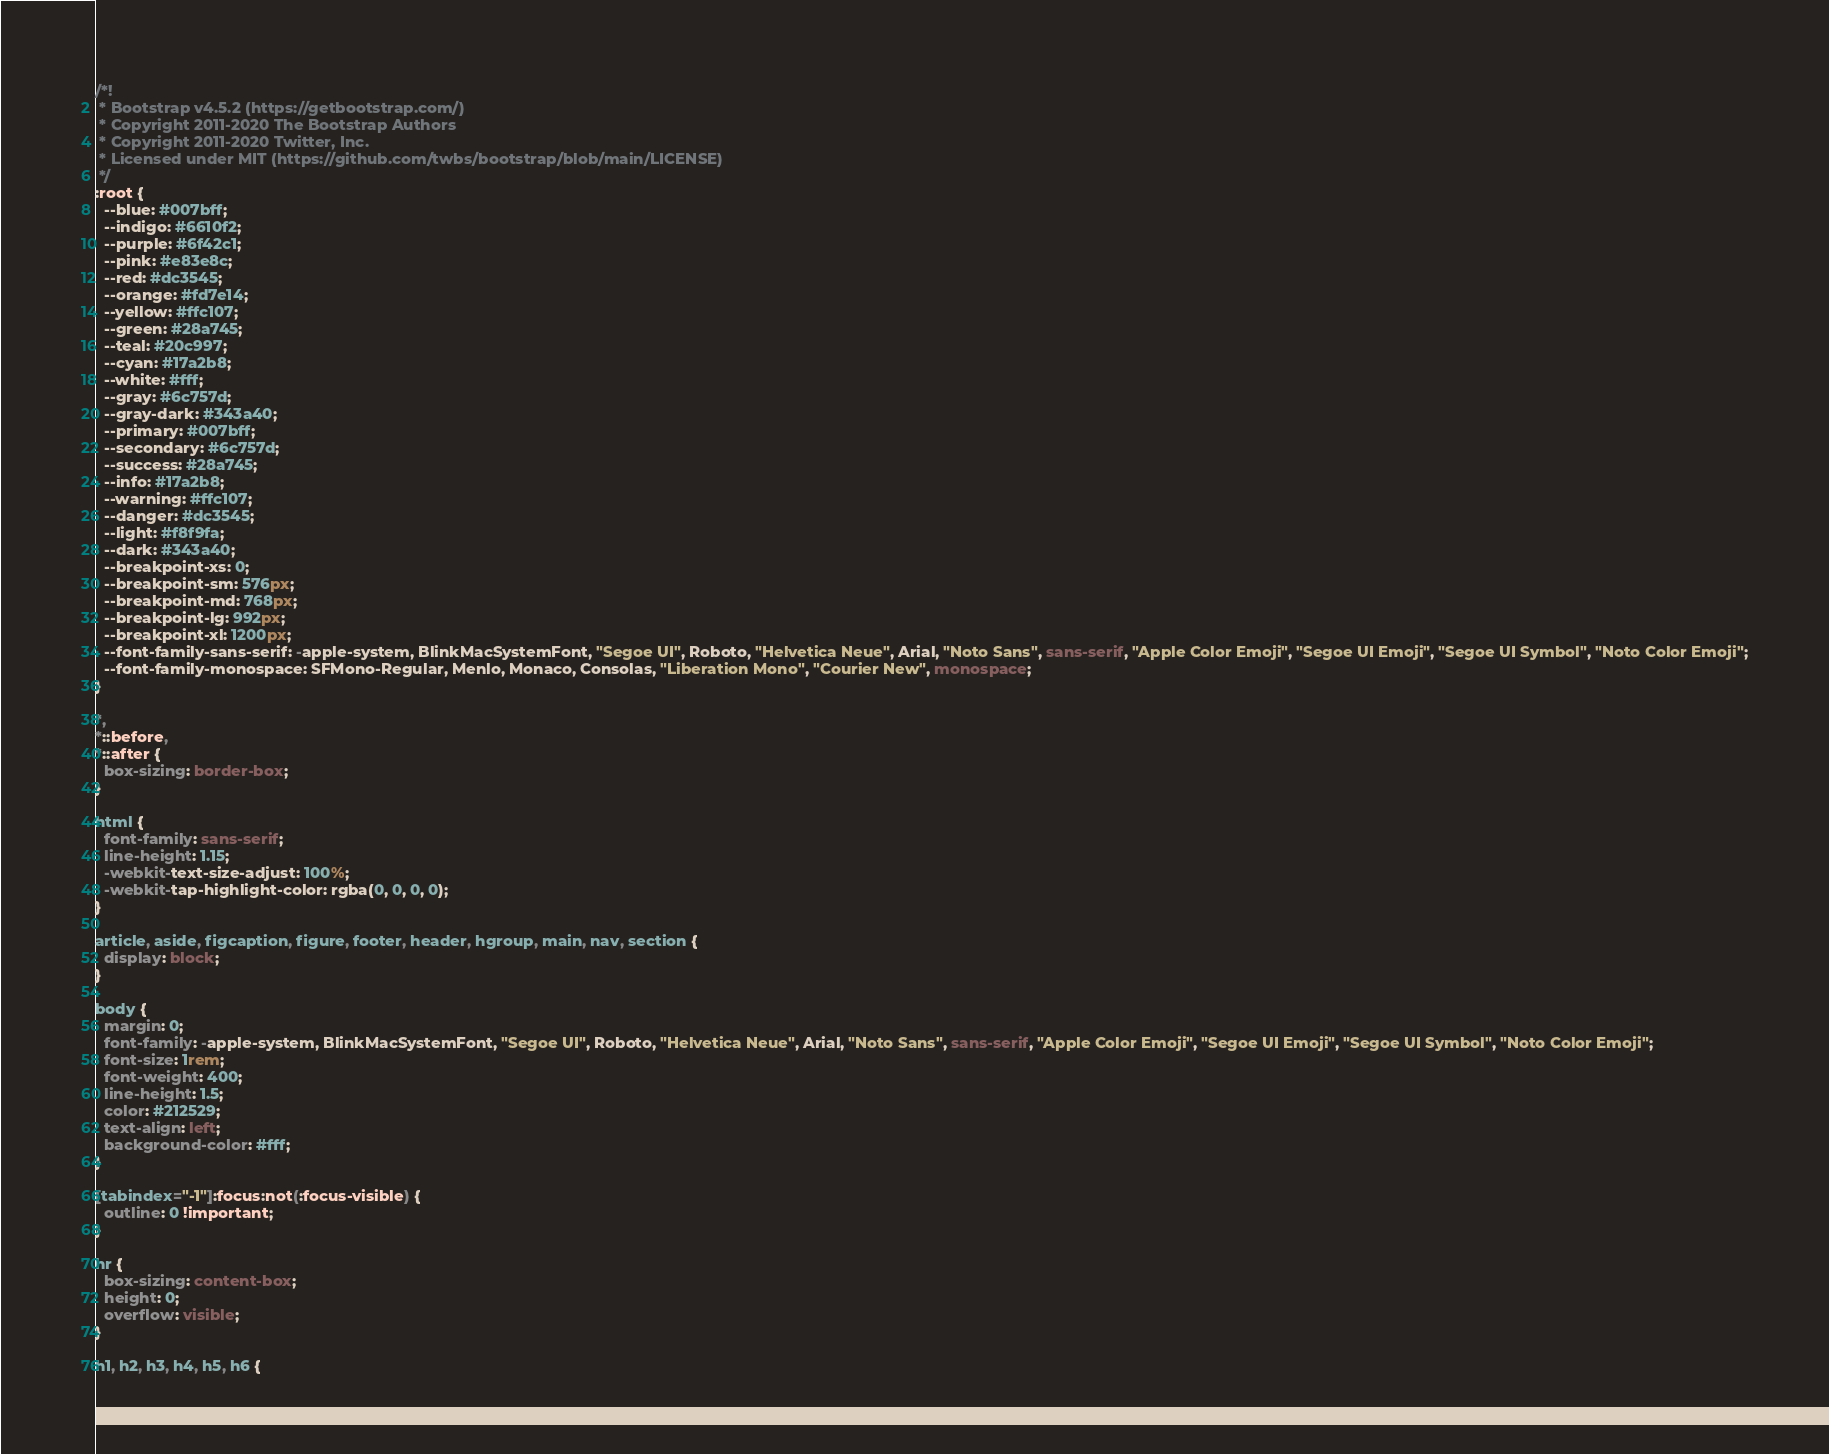Convert code to text. <code><loc_0><loc_0><loc_500><loc_500><_CSS_>/*!
 * Bootstrap v4.5.2 (https://getbootstrap.com/)
 * Copyright 2011-2020 The Bootstrap Authors
 * Copyright 2011-2020 Twitter, Inc.
 * Licensed under MIT (https://github.com/twbs/bootstrap/blob/main/LICENSE)
 */
:root {
  --blue: #007bff;
  --indigo: #6610f2;
  --purple: #6f42c1;
  --pink: #e83e8c;
  --red: #dc3545;
  --orange: #fd7e14;
  --yellow: #ffc107;
  --green: #28a745;
  --teal: #20c997;
  --cyan: #17a2b8;
  --white: #fff;
  --gray: #6c757d;
  --gray-dark: #343a40;
  --primary: #007bff;
  --secondary: #6c757d;
  --success: #28a745;
  --info: #17a2b8;
  --warning: #ffc107;
  --danger: #dc3545;
  --light: #f8f9fa;
  --dark: #343a40;
  --breakpoint-xs: 0;
  --breakpoint-sm: 576px;
  --breakpoint-md: 768px;
  --breakpoint-lg: 992px;
  --breakpoint-xl: 1200px;
  --font-family-sans-serif: -apple-system, BlinkMacSystemFont, "Segoe UI", Roboto, "Helvetica Neue", Arial, "Noto Sans", sans-serif, "Apple Color Emoji", "Segoe UI Emoji", "Segoe UI Symbol", "Noto Color Emoji";
  --font-family-monospace: SFMono-Regular, Menlo, Monaco, Consolas, "Liberation Mono", "Courier New", monospace;
}

*,
*::before,
*::after {
  box-sizing: border-box;
}

html {
  font-family: sans-serif;
  line-height: 1.15;
  -webkit-text-size-adjust: 100%;
  -webkit-tap-highlight-color: rgba(0, 0, 0, 0);
}

article, aside, figcaption, figure, footer, header, hgroup, main, nav, section {
  display: block;
}

body {
  margin: 0;
  font-family: -apple-system, BlinkMacSystemFont, "Segoe UI", Roboto, "Helvetica Neue", Arial, "Noto Sans", sans-serif, "Apple Color Emoji", "Segoe UI Emoji", "Segoe UI Symbol", "Noto Color Emoji";
  font-size: 1rem;
  font-weight: 400;
  line-height: 1.5;
  color: #212529;
  text-align: left;
  background-color: #fff;
}

[tabindex="-1"]:focus:not(:focus-visible) {
  outline: 0 !important;
}

hr {
  box-sizing: content-box;
  height: 0;
  overflow: visible;
}

h1, h2, h3, h4, h5, h6 {</code> 